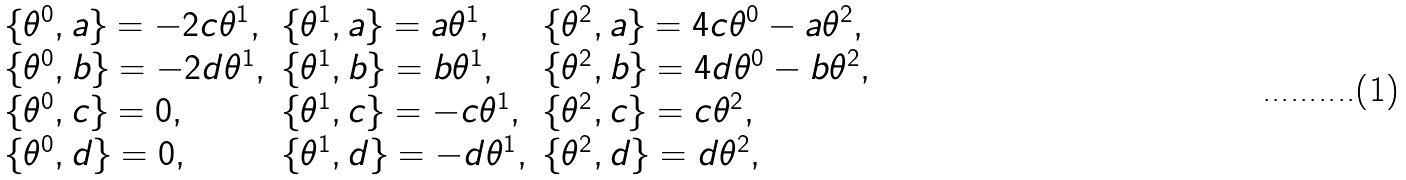<formula> <loc_0><loc_0><loc_500><loc_500>\begin{array} { l l l } \{ \theta ^ { 0 } , a \} = - 2 c \theta ^ { 1 } , & \{ \theta ^ { 1 } , a \} = a \theta ^ { 1 } , & \{ \theta ^ { 2 } , a \} = 4 c \theta ^ { 0 } - a \theta ^ { 2 } , \\ \{ \theta ^ { 0 } , b \} = - 2 d \theta ^ { 1 } , & \{ \theta ^ { 1 } , b \} = b \theta ^ { 1 } , & \{ \theta ^ { 2 } , b \} = 4 d \theta ^ { 0 } - b \theta ^ { 2 } , \\ \{ \theta ^ { 0 } , c \} = 0 , & \{ \theta ^ { 1 } , c \} = - c \theta ^ { 1 } , & \{ \theta ^ { 2 } , c \} = c \theta ^ { 2 } , \\ \{ \theta ^ { 0 } , d \} = 0 , & \{ \theta ^ { 1 } , d \} = - d \theta ^ { 1 } , & \{ \theta ^ { 2 } , d \} = d \theta ^ { 2 } , \end{array}</formula> 